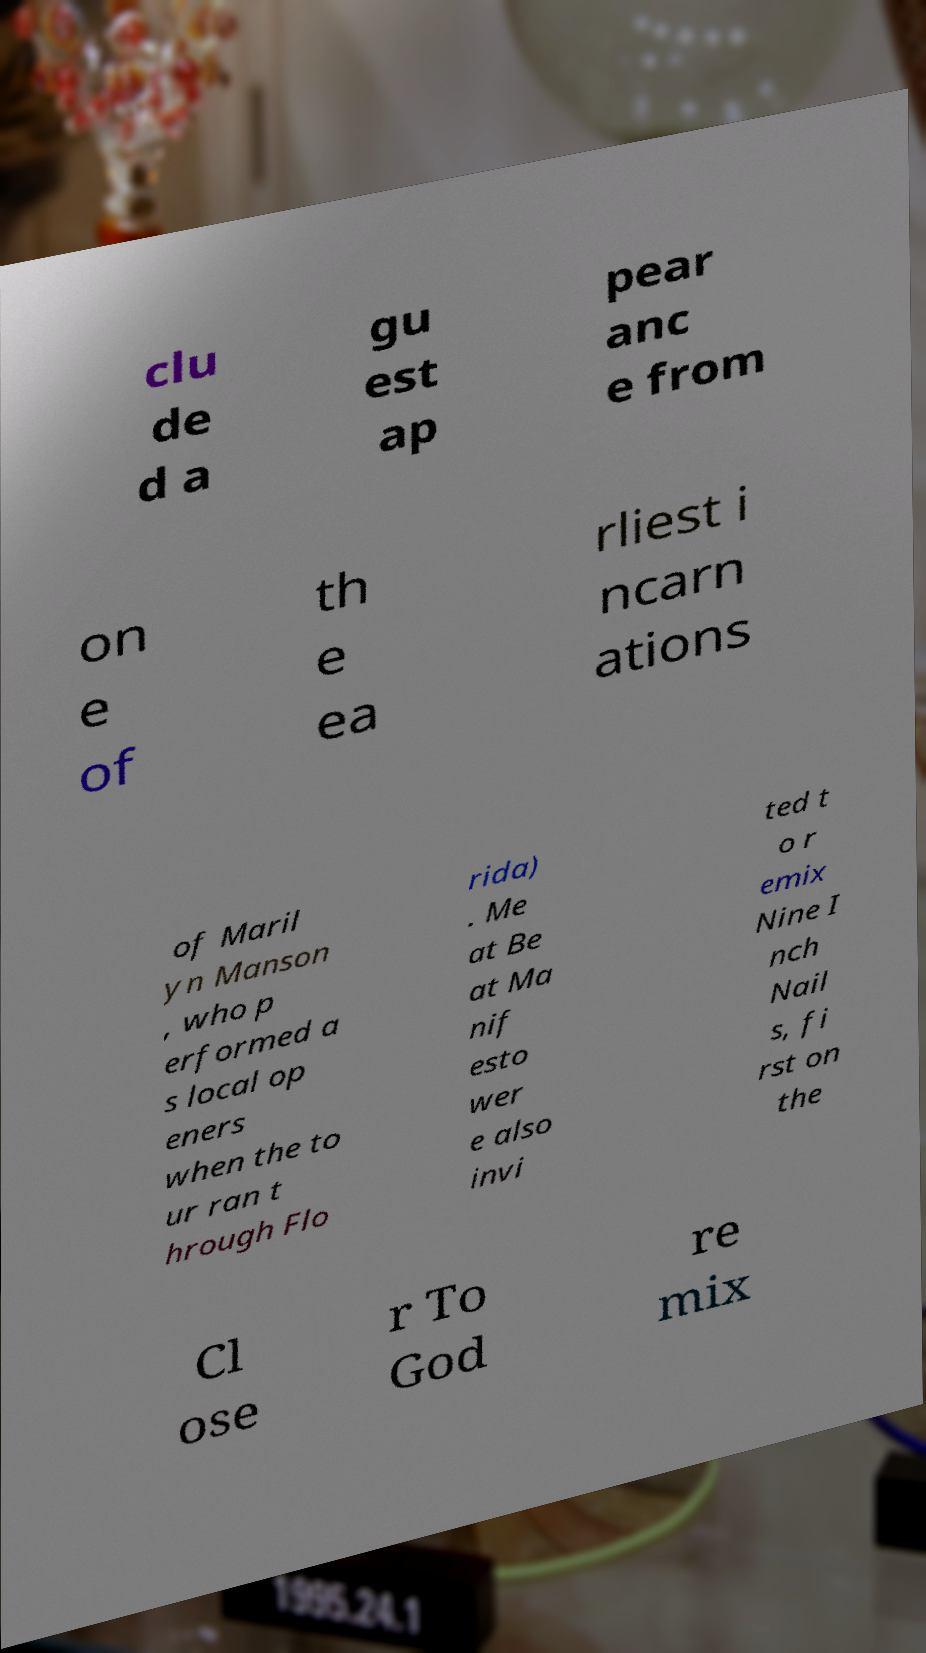Can you read and provide the text displayed in the image?This photo seems to have some interesting text. Can you extract and type it out for me? clu de d a gu est ap pear anc e from on e of th e ea rliest i ncarn ations of Maril yn Manson , who p erformed a s local op eners when the to ur ran t hrough Flo rida) . Me at Be at Ma nif esto wer e also invi ted t o r emix Nine I nch Nail s, fi rst on the Cl ose r To God re mix 